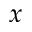Convert formula to latex. <formula><loc_0><loc_0><loc_500><loc_500>x</formula> 